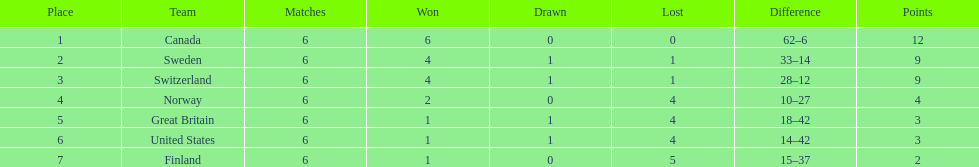Which two nations are being referred to? Switzerland, Great Britain. What were the scores for each of these nations? 9, 3. Among these scores, which is superior? 9. Which nation achieved this score? Switzerland. 